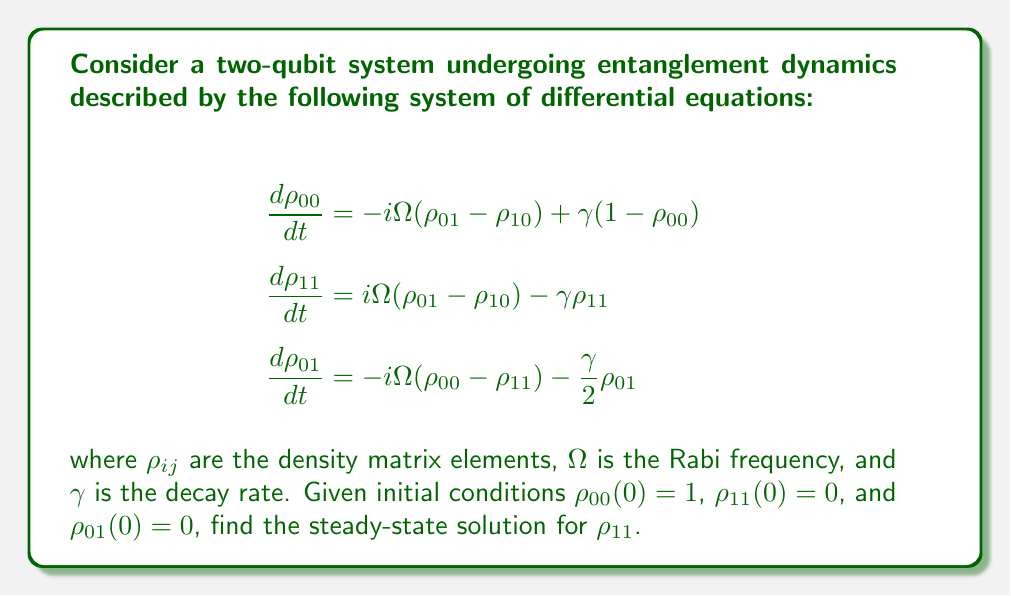What is the answer to this math problem? To solve this system of differential equations and find the steady-state solution for $\rho_{11}$, we follow these steps:

1) In the steady-state, all time derivatives are zero. Set $\frac{d\rho_{ij}}{dt} = 0$ for all $ij$:

   $$\begin{align}
   0 &= -i\Omega(\rho_{01} - \rho_{10}) + \gamma(1-\rho_{00}) \\
   0 &= i\Omega(\rho_{01} - \rho_{10}) - \gamma\rho_{11} \\
   0 &= -i\Omega(\rho_{00} - \rho_{11}) - \frac{\gamma}{2}\rho_{01}
   \end{align}$$

2) Note that $\rho_{10} = \rho_{01}^*$ (complex conjugate) due to the Hermitian property of density matrices.

3) From the third equation:
   $$\rho_{01} = -\frac{2i\Omega}{\gamma}(\rho_{00} - \rho_{11})$$

4) Substitute this into the first equation:
   $$0 = -i\Omega\left(-\frac{2i\Omega}{\gamma}(\rho_{00} - \rho_{11}) - \frac{2i\Omega}{\gamma}(\rho_{00} - \rho_{11})\right) + \gamma(1-\rho_{00})$$

5) Simplify:
   $$0 = \frac{4\Omega^2}{\gamma}(\rho_{00} - \rho_{11}) + \gamma(1-\rho_{00})$$

6) We know that $\rho_{00} + \rho_{11} = 1$ (trace of density matrix is 1). Use this to eliminate $\rho_{00}$:
   $$0 = \frac{4\Omega^2}{\gamma}(1 - 2\rho_{11}) + \gamma\rho_{11}$$

7) Solve for $\rho_{11}$:
   $$\rho_{11} = \frac{4\Omega^2}{4\Omega^2 + \gamma^2}$$

This is the steady-state solution for $\rho_{11}$.
Answer: $\rho_{11} = \frac{4\Omega^2}{4\Omega^2 + \gamma^2}$ 